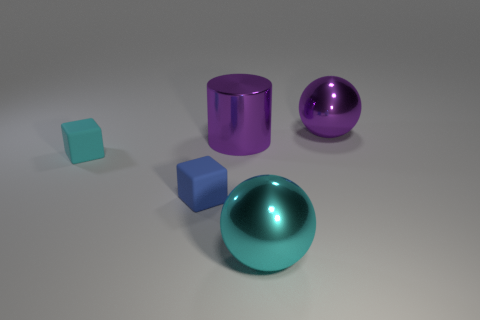Add 2 tiny rubber balls. How many objects exist? 7 Subtract all spheres. How many objects are left? 3 Subtract 0 brown spheres. How many objects are left? 5 Subtract all large cyan things. Subtract all small matte objects. How many objects are left? 2 Add 5 cyan rubber blocks. How many cyan rubber blocks are left? 6 Add 2 small blue things. How many small blue things exist? 3 